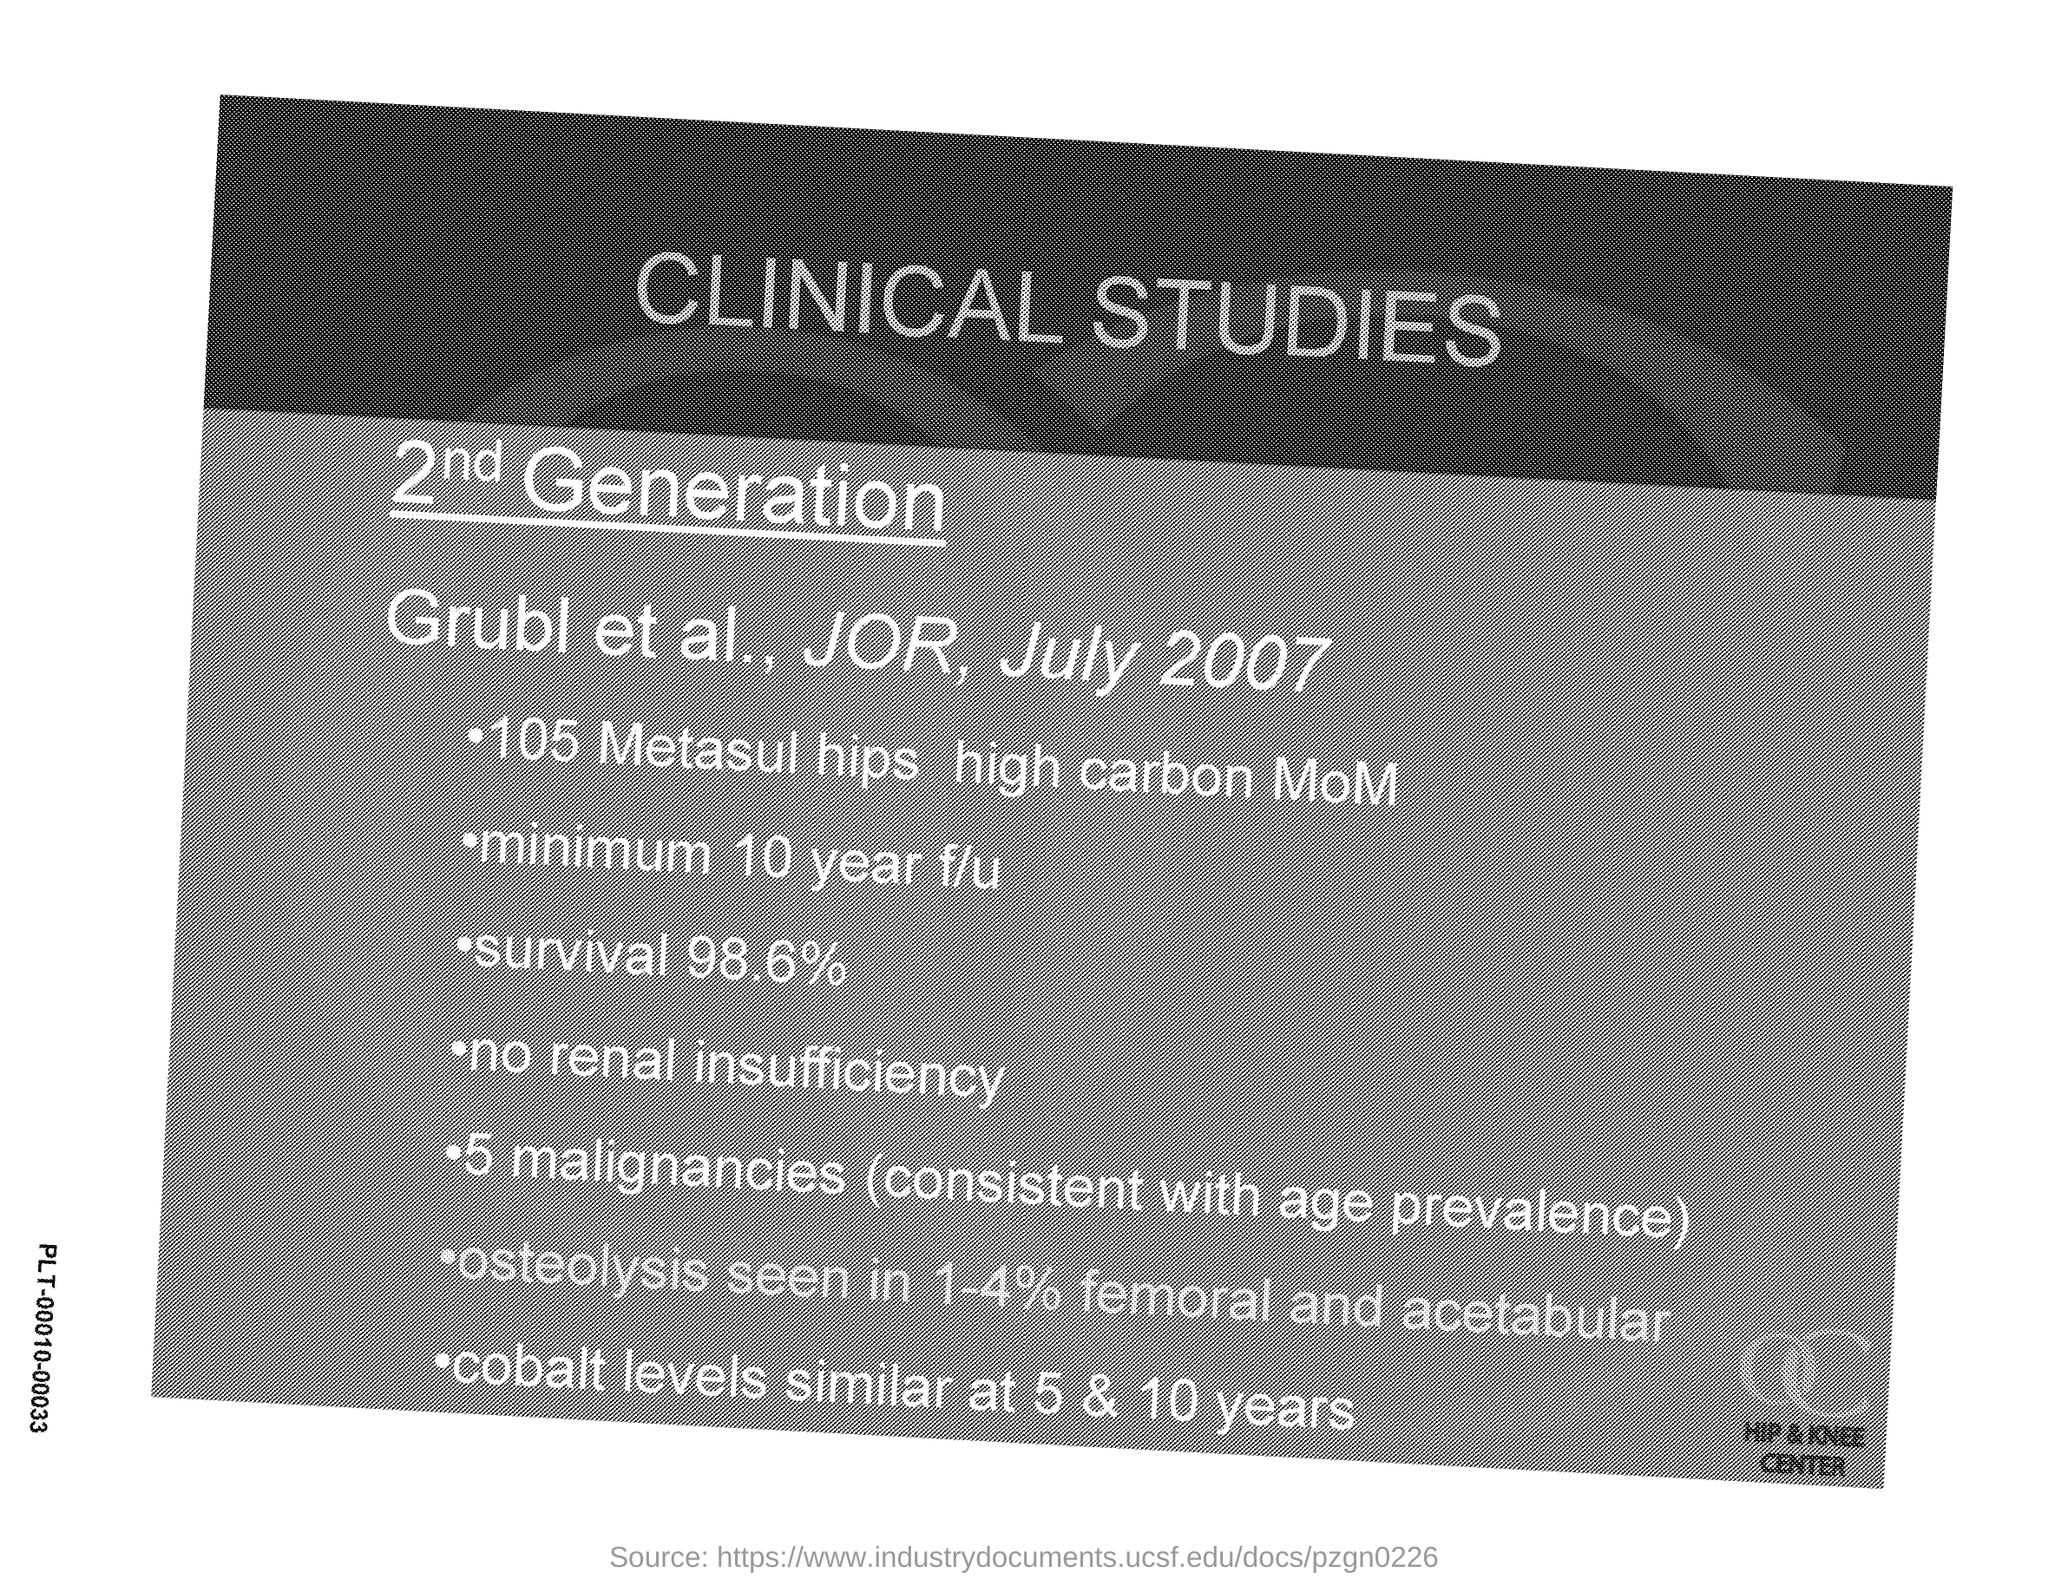What is the Title of the document?
Your answer should be compact. Clinical Studies. What is the date on the document?
Keep it short and to the point. July 2007. 